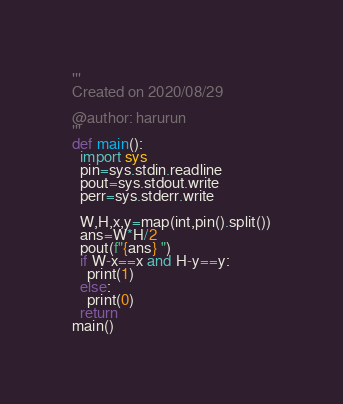<code> <loc_0><loc_0><loc_500><loc_500><_Python_>'''
Created on 2020/08/29

@author: harurun
'''
def main():
  import sys
  pin=sys.stdin.readline
  pout=sys.stdout.write
  perr=sys.stderr.write
  
  W,H,x,y=map(int,pin().split())
  ans=W*H/2
  pout(f"{ans} ")
  if W-x==x and H-y==y:
    print(1)
  else:
    print(0)
  return 
main()</code> 